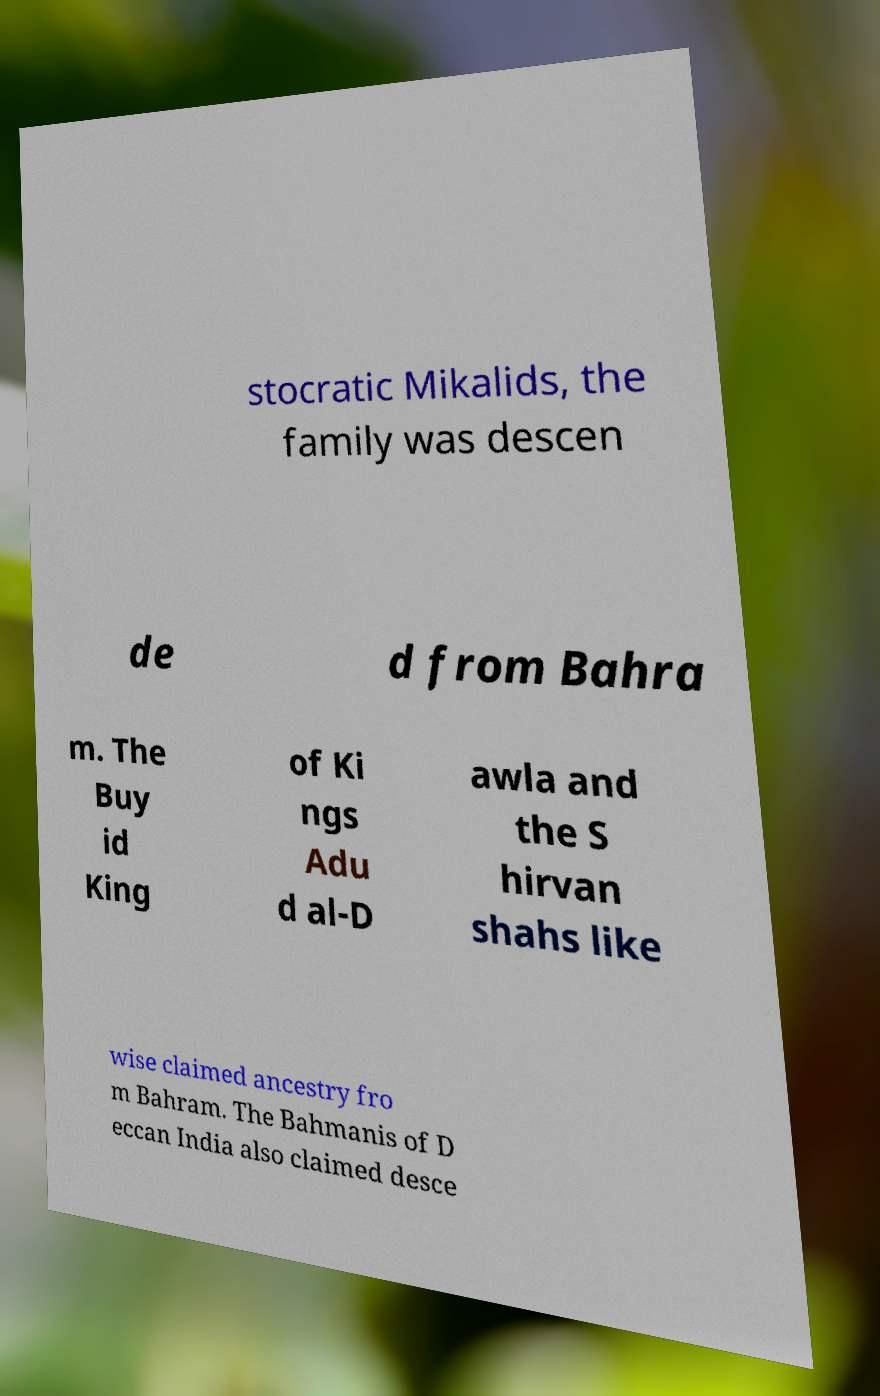There's text embedded in this image that I need extracted. Can you transcribe it verbatim? stocratic Mikalids, the family was descen de d from Bahra m. The Buy id King of Ki ngs Adu d al-D awla and the S hirvan shahs like wise claimed ancestry fro m Bahram. The Bahmanis of D eccan India also claimed desce 